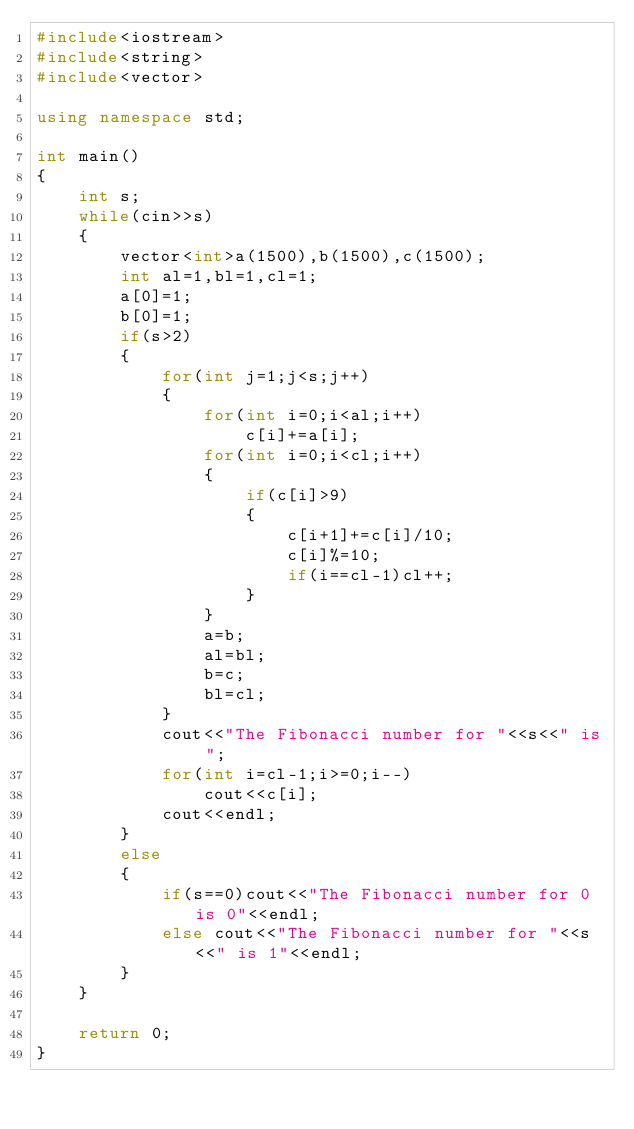Convert code to text. <code><loc_0><loc_0><loc_500><loc_500><_C++_>#include<iostream>
#include<string>
#include<vector>

using namespace std;

int main()
{
    int s;
    while(cin>>s)
    {
        vector<int>a(1500),b(1500),c(1500);
        int al=1,bl=1,cl=1;
        a[0]=1;
        b[0]=1;
        if(s>2)
        {
            for(int j=1;j<s;j++)
            {
                for(int i=0;i<al;i++)
                    c[i]+=a[i];
                for(int i=0;i<cl;i++)
                {
                    if(c[i]>9)
                    {
                        c[i+1]+=c[i]/10;
                        c[i]%=10;
                        if(i==cl-1)cl++;
                    }
                }
                a=b;
                al=bl;
                b=c;
                bl=cl;
            }
            cout<<"The Fibonacci number for "<<s<<" is ";
            for(int i=cl-1;i>=0;i--)
                cout<<c[i];
            cout<<endl;
        }
        else
        {
            if(s==0)cout<<"The Fibonacci number for 0 is 0"<<endl;
            else cout<<"The Fibonacci number for "<<s<<" is 1"<<endl;
        }
    }

    return 0;
}
</code> 